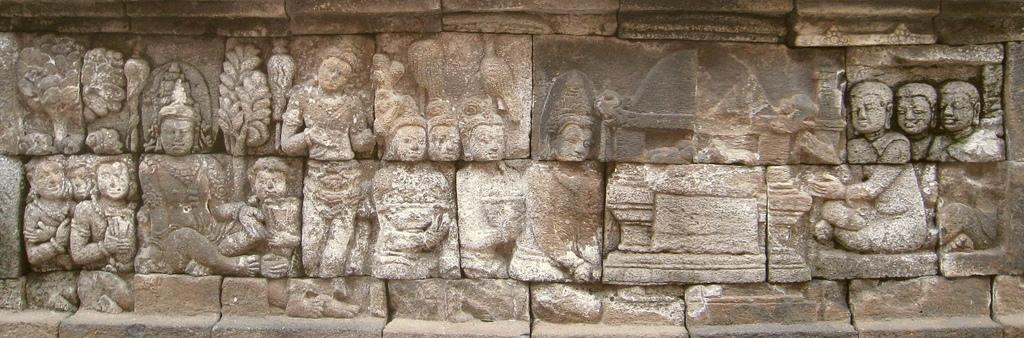What is depicted on the wall in the image? There are sculptures on the wall in the image. What type of mint can be seen growing near the sculptures in the image? There is no mint present in the image; it only features sculptures on the wall. 